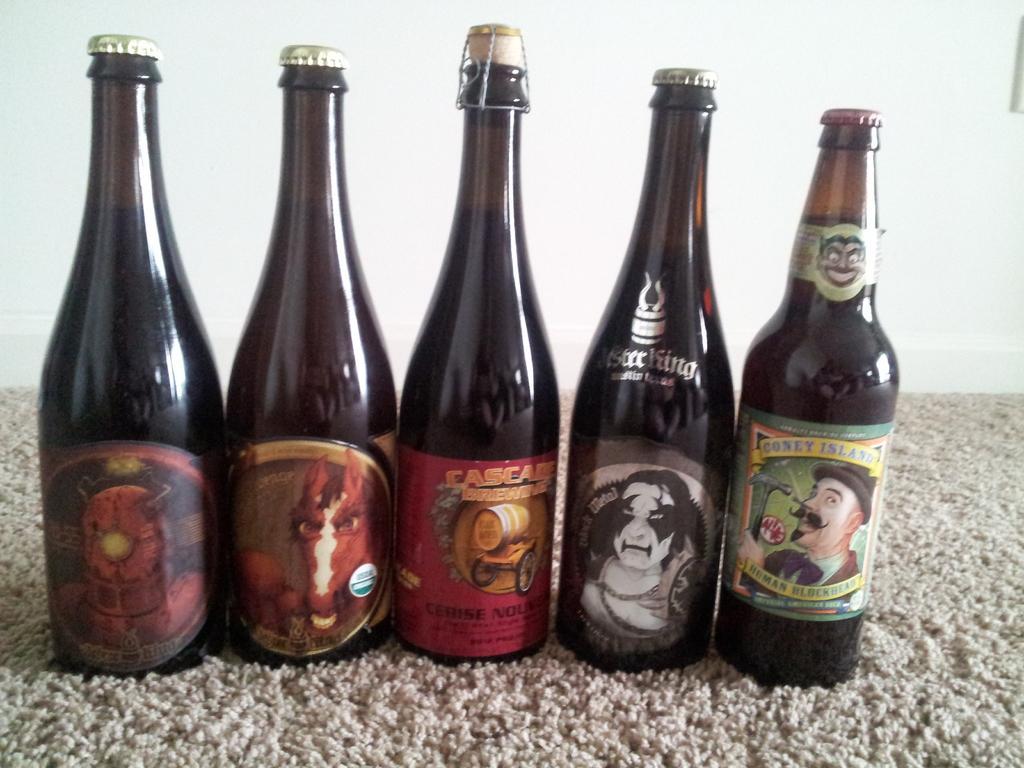Describe this image in one or two sentences. In this image we can see a bottle and a floor mat. 